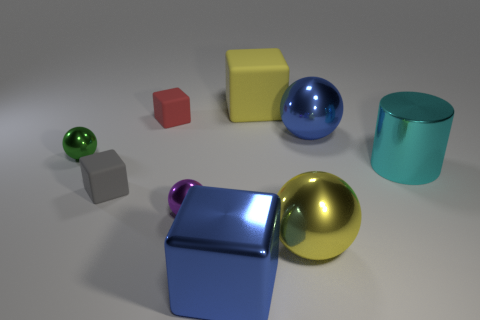Can you tell me what the small green object is? The small green object appears to be a sphere, similar in shape to the larger blue sphere, but significantly smaller in size. 